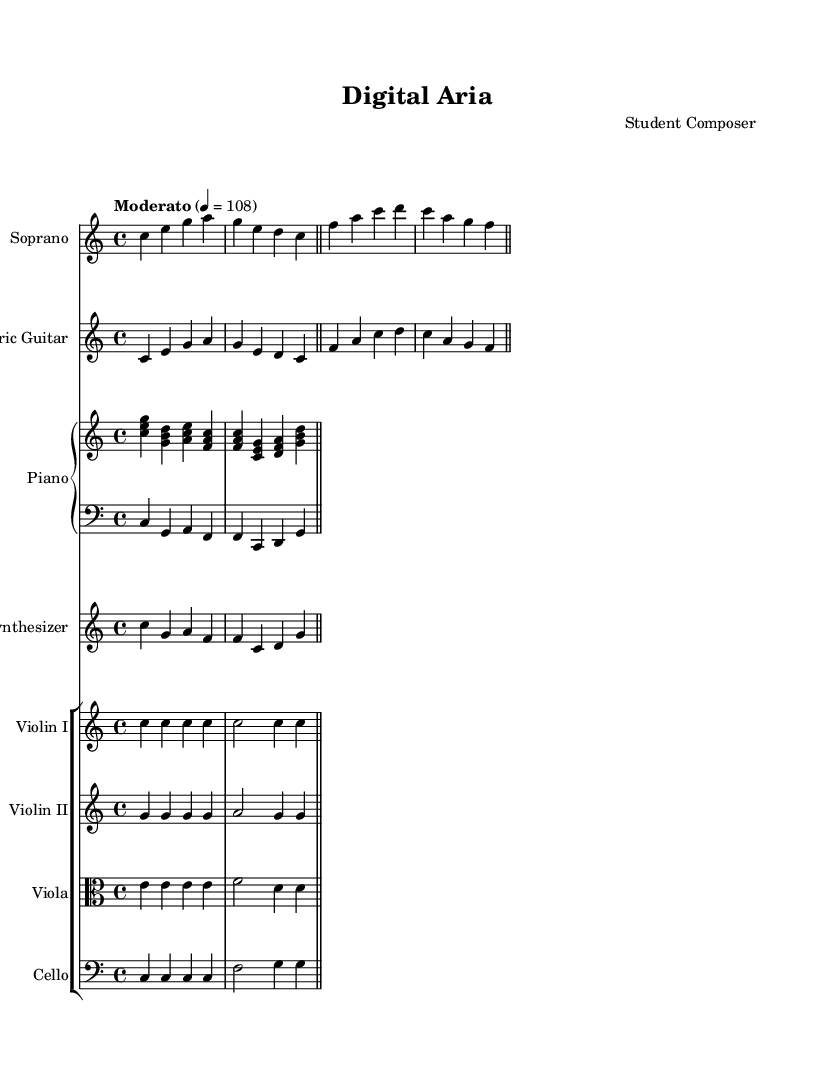What is the key signature of this music? The key signature is found at the beginning of the score, and it indicates that there are no sharps or flats present in the music. This corresponds to C major.
Answer: C major What is the time signature of the piece? The time signature is located at the beginning of the score, represented as 4/4, which indicates that there are four beats in each measure and the quarter note gets one beat.
Answer: 4/4 What is the indicated tempo of the piece? The tempo marking is written above the staff, where it states "Moderato" and gives a specific metronome marking of 108 beats per minute, indicating a moderate speed.
Answer: Moderato 4 = 108 How many instruments are featured in this composition? By counting the different staves provided in the score, we can see there are six unique instrument names mentioned, including Soprano, Electric Guitar, Piano, Synthesizer, Violin I, Violin II, Viola, and Cello, which gives a total of eight.
Answer: Eight Which instruments play in unison for the first section? Looking at the first few measures, both the Soprano and Electric Guitar play the same melody line, indicating they are in unison during that section.
Answer: Soprano and Electric Guitar What instrument has a bass clef staff? The Piano has two staffs where one is in a treble clef, and the second one is in a bass clef, indicating the lower register played by the left hand.
Answer: Piano Left In which section do the violins predominantly play identical notes? The score shows that Violin I and Violin II both play the note "g" in their designated measures, suggesting they are playing identical rhythms and pitches for that section.
Answer: Measures with "g" notes 